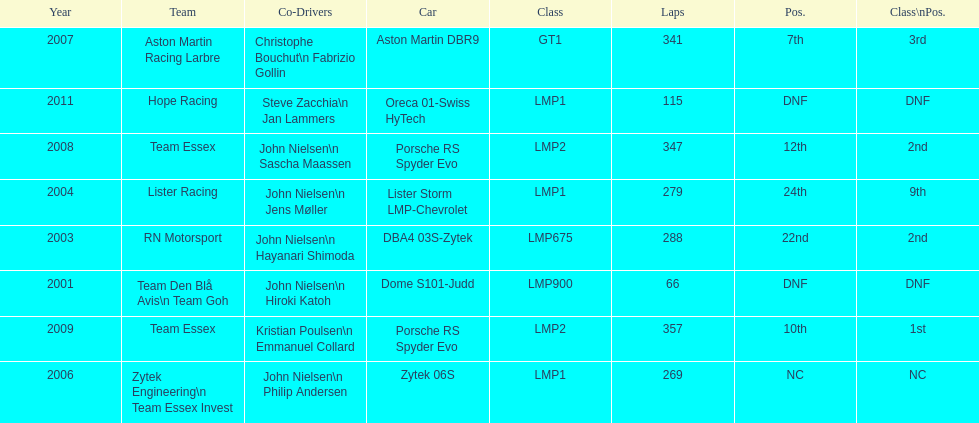What is the amount races that were competed in? 8. 